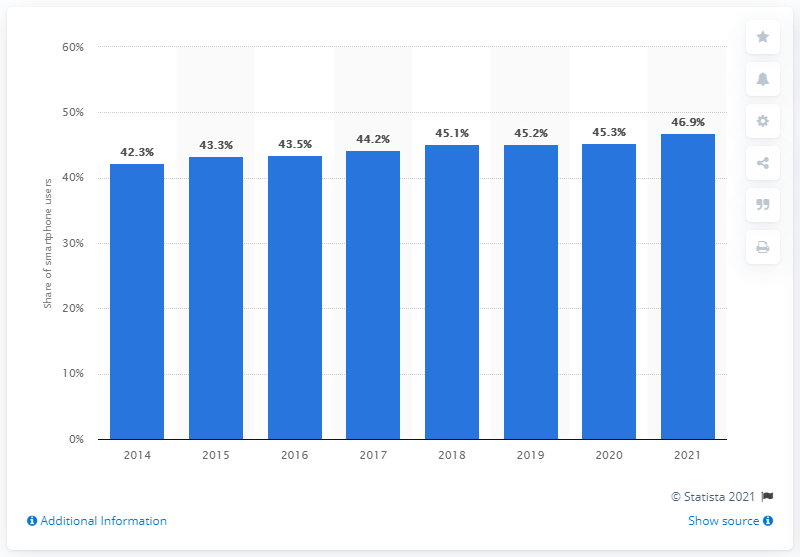Specify some key components in this picture. In 2021, the tallest bar was present. Approximately 46.9% of all smartphone users in the US own an iPhone. The share of smartphone users in the US who use an Apple iPhone is increasing over time. 